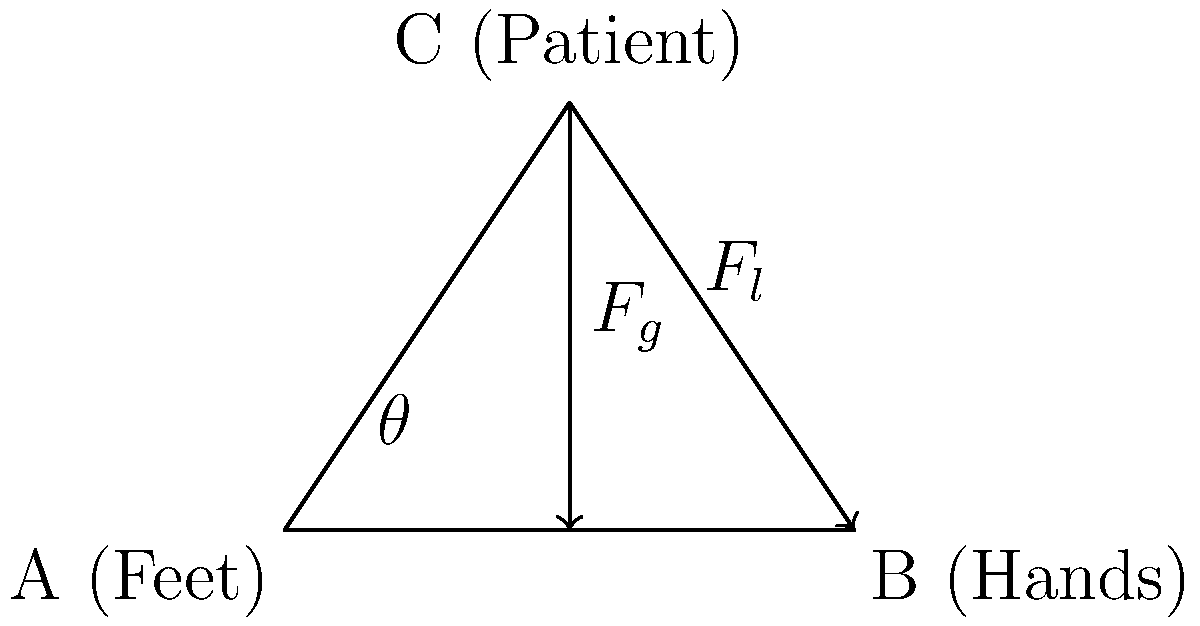In proper patient lifting techniques, a nurse forms a triangle with their feet (A), hands (B), and the patient's center of mass (C). If the angle between the floor and the nurse's arms (θ) is 40°, and the patient weighs 80 kg, what is the magnitude of the force (in Newtons) exerted by the nurse's arms to lift the patient? To solve this problem, we'll follow these steps:

1. Identify the forces involved:
   - $F_g$: Gravitational force on the patient (weight)
   - $F_l$: Lifting force exerted by the nurse's arms

2. Calculate the patient's weight in Newtons:
   $F_g = 80 \text{ kg} \times 9.8 \text{ m/s}^2 = 784 \text{ N}$

3. Use trigonometry to find the relationship between $F_g$ and $F_l$:
   $\sin(40°) = \frac{F_g}{F_l}$

4. Rearrange the equation to solve for $F_l$:
   $F_l = \frac{F_g}{\sin(40°)}$

5. Substitute the known values and calculate:
   $F_l = \frac{784 \text{ N}}{\sin(40°)} \approx 1219.4 \text{ N}$

6. Round to the nearest whole number:
   $F_l \approx 1219 \text{ N}$

Therefore, the magnitude of the force exerted by the nurse's arms to lift the patient is approximately 1219 N.
Answer: 1219 N 